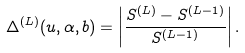Convert formula to latex. <formula><loc_0><loc_0><loc_500><loc_500>\Delta ^ { ( L ) } ( u , \alpha , b ) = \left | \frac { S ^ { ( L ) } - S ^ { ( L - 1 ) } } { S ^ { ( L - 1 ) } } \right | .</formula> 